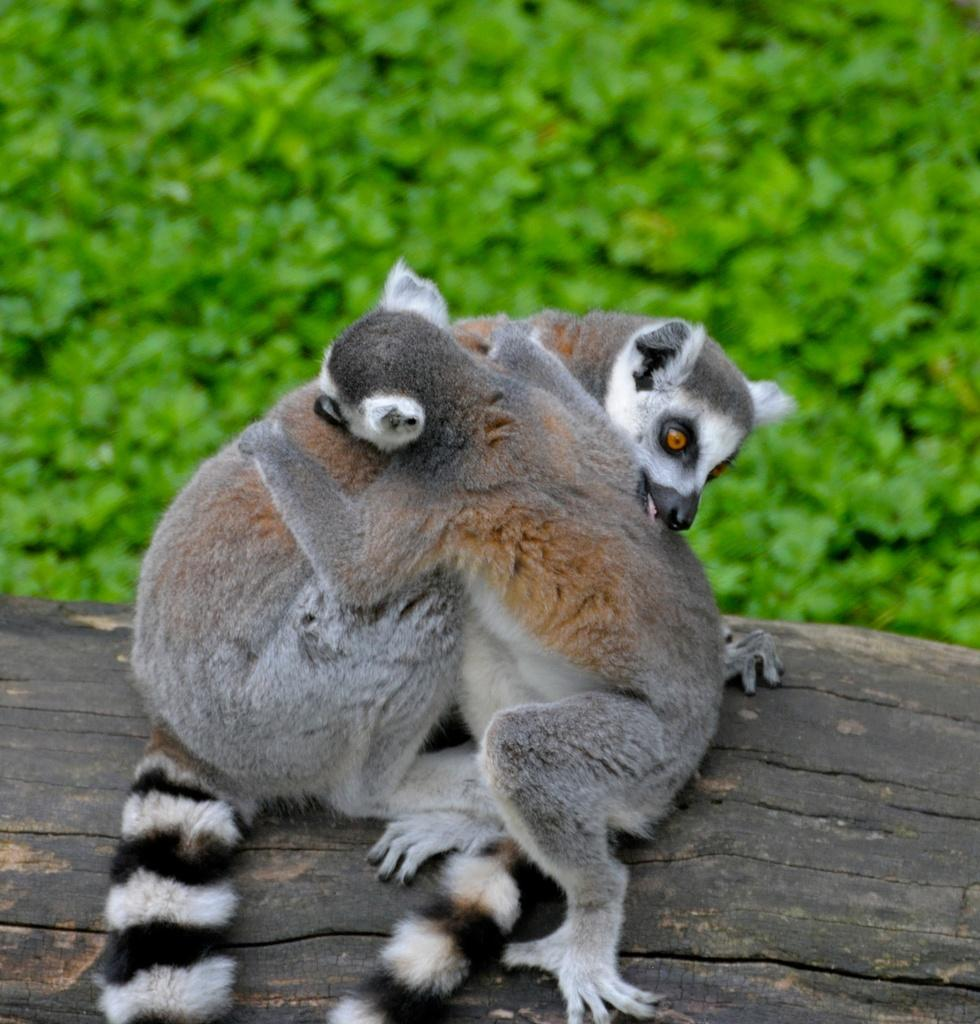What is located in the middle of the image? There are animals in the middle of the image. What can be seen in the background of the image? There are plants in the background of the image. What type of flower is being played on the record in the image? There is no flower or record present in the image; it features animals and plants. How many wings can be seen on the animals in the image? The provided facts do not mention any specific animals or their features, so we cannot determine the number of wings. 